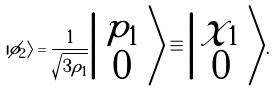Convert formula to latex. <formula><loc_0><loc_0><loc_500><loc_500>| \phi _ { 2 } \rangle = \frac { 1 } { \sqrt { 3 \rho _ { 1 } } } \Big | \begin{array} { c } { p } _ { 1 } \\ 0 \end{array} \Big \rangle \equiv \Big | \begin{array} { c } \chi _ { 1 } \\ 0 \end{array} \Big \rangle .</formula> 